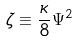Convert formula to latex. <formula><loc_0><loc_0><loc_500><loc_500>\zeta \equiv \frac { \kappa } { 8 } \Psi ^ { 2 }</formula> 